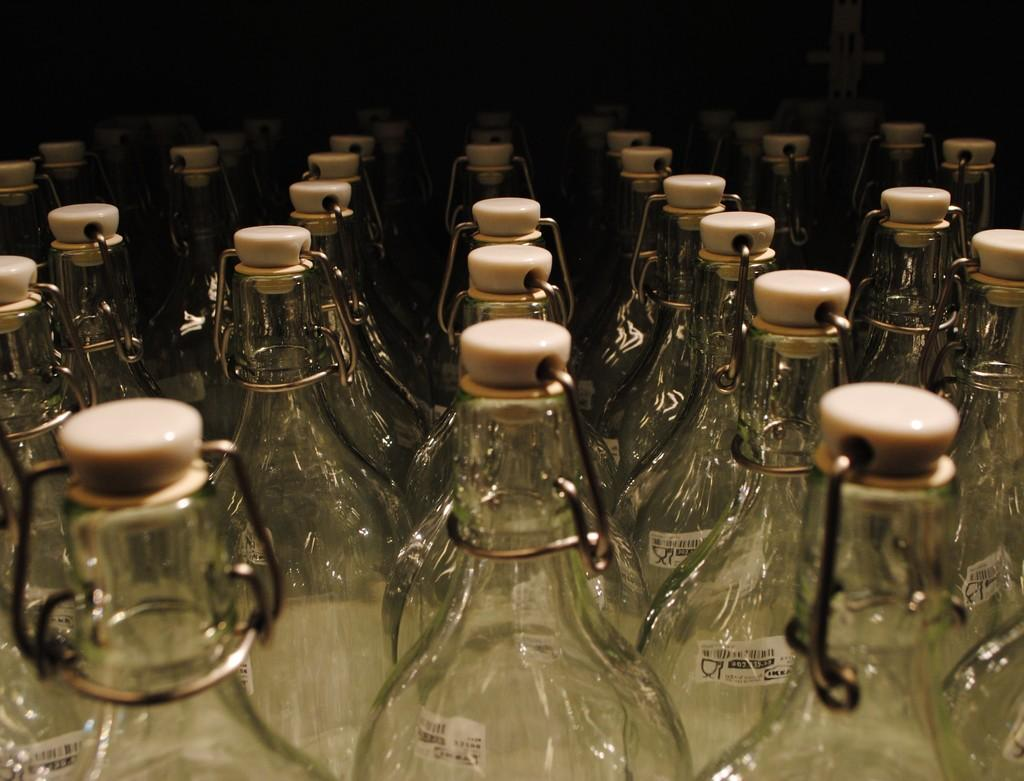What is the main subject of the image? The main subject of the image is many bottles. What can be seen on each bottle in the image? Each bottle has a sticker in the image. What is used to seal the bottles in the image? Each bottle has a cap in the image. Can you tell me how deep the quicksand is in the image? There is no quicksand present in the image. What is the level of the hole in the image? There is no hole present in the image. 